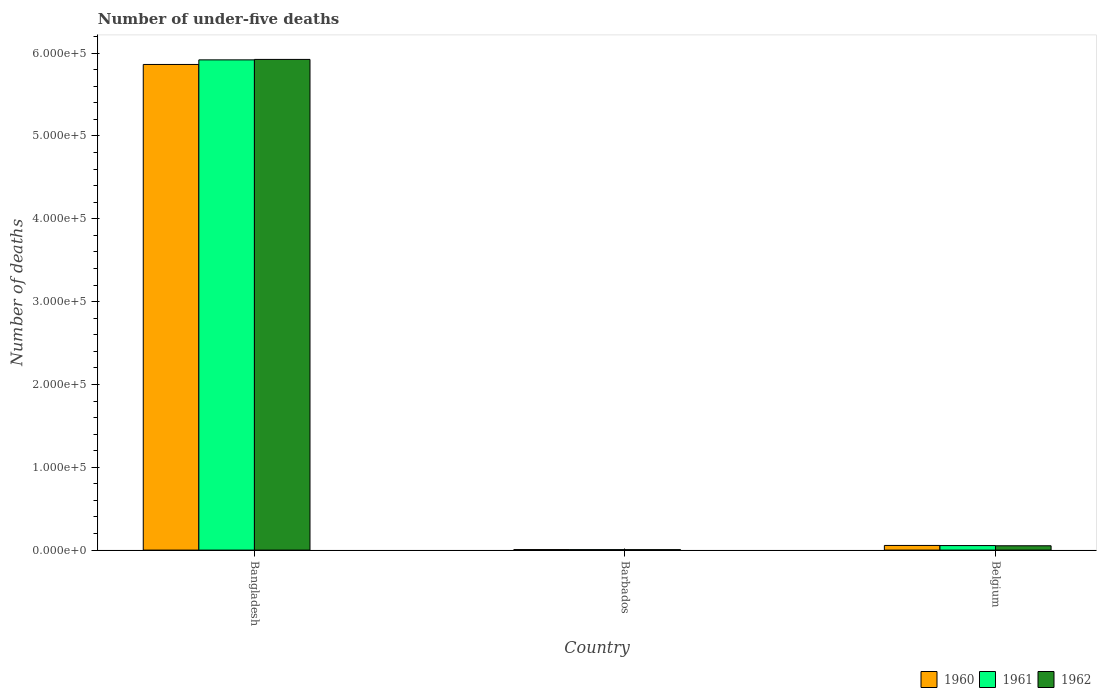How many groups of bars are there?
Give a very brief answer. 3. Are the number of bars per tick equal to the number of legend labels?
Give a very brief answer. Yes. How many bars are there on the 3rd tick from the left?
Provide a succinct answer. 3. How many bars are there on the 2nd tick from the right?
Your answer should be compact. 3. What is the label of the 2nd group of bars from the left?
Offer a terse response. Barbados. What is the number of under-five deaths in 1962 in Bangladesh?
Make the answer very short. 5.92e+05. Across all countries, what is the maximum number of under-five deaths in 1961?
Provide a short and direct response. 5.92e+05. Across all countries, what is the minimum number of under-five deaths in 1960?
Provide a short and direct response. 615. In which country was the number of under-five deaths in 1962 maximum?
Offer a very short reply. Bangladesh. In which country was the number of under-five deaths in 1961 minimum?
Offer a terse response. Barbados. What is the total number of under-five deaths in 1962 in the graph?
Make the answer very short. 5.98e+05. What is the difference between the number of under-five deaths in 1961 in Barbados and that in Belgium?
Offer a very short reply. -4887. What is the difference between the number of under-five deaths in 1962 in Bangladesh and the number of under-five deaths in 1961 in Belgium?
Provide a short and direct response. 5.87e+05. What is the average number of under-five deaths in 1960 per country?
Provide a succinct answer. 1.98e+05. What is the difference between the number of under-five deaths of/in 1962 and number of under-five deaths of/in 1961 in Belgium?
Provide a short and direct response. -232. What is the ratio of the number of under-five deaths in 1960 in Bangladesh to that in Barbados?
Keep it short and to the point. 953.38. What is the difference between the highest and the second highest number of under-five deaths in 1962?
Your response must be concise. -5.92e+05. What is the difference between the highest and the lowest number of under-five deaths in 1961?
Offer a very short reply. 5.91e+05. In how many countries, is the number of under-five deaths in 1960 greater than the average number of under-five deaths in 1960 taken over all countries?
Offer a very short reply. 1. Is the sum of the number of under-five deaths in 1961 in Bangladesh and Belgium greater than the maximum number of under-five deaths in 1962 across all countries?
Make the answer very short. Yes. How many bars are there?
Ensure brevity in your answer.  9. Does the graph contain any zero values?
Give a very brief answer. No. Does the graph contain grids?
Give a very brief answer. No. How are the legend labels stacked?
Provide a succinct answer. Horizontal. What is the title of the graph?
Provide a succinct answer. Number of under-five deaths. Does "1967" appear as one of the legend labels in the graph?
Ensure brevity in your answer.  No. What is the label or title of the X-axis?
Offer a terse response. Country. What is the label or title of the Y-axis?
Give a very brief answer. Number of deaths. What is the Number of deaths in 1960 in Bangladesh?
Your answer should be compact. 5.86e+05. What is the Number of deaths of 1961 in Bangladesh?
Provide a succinct answer. 5.92e+05. What is the Number of deaths of 1962 in Bangladesh?
Your response must be concise. 5.92e+05. What is the Number of deaths of 1960 in Barbados?
Provide a succinct answer. 615. What is the Number of deaths of 1961 in Barbados?
Provide a short and direct response. 574. What is the Number of deaths of 1962 in Barbados?
Provide a succinct answer. 536. What is the Number of deaths of 1960 in Belgium?
Ensure brevity in your answer.  5614. What is the Number of deaths of 1961 in Belgium?
Provide a succinct answer. 5461. What is the Number of deaths of 1962 in Belgium?
Provide a succinct answer. 5229. Across all countries, what is the maximum Number of deaths in 1960?
Ensure brevity in your answer.  5.86e+05. Across all countries, what is the maximum Number of deaths in 1961?
Offer a very short reply. 5.92e+05. Across all countries, what is the maximum Number of deaths in 1962?
Provide a short and direct response. 5.92e+05. Across all countries, what is the minimum Number of deaths of 1960?
Keep it short and to the point. 615. Across all countries, what is the minimum Number of deaths of 1961?
Give a very brief answer. 574. Across all countries, what is the minimum Number of deaths of 1962?
Offer a terse response. 536. What is the total Number of deaths in 1960 in the graph?
Your answer should be compact. 5.93e+05. What is the total Number of deaths in 1961 in the graph?
Your response must be concise. 5.98e+05. What is the total Number of deaths in 1962 in the graph?
Your answer should be compact. 5.98e+05. What is the difference between the Number of deaths of 1960 in Bangladesh and that in Barbados?
Keep it short and to the point. 5.86e+05. What is the difference between the Number of deaths in 1961 in Bangladesh and that in Barbados?
Provide a short and direct response. 5.91e+05. What is the difference between the Number of deaths in 1962 in Bangladesh and that in Barbados?
Give a very brief answer. 5.92e+05. What is the difference between the Number of deaths in 1960 in Bangladesh and that in Belgium?
Your answer should be very brief. 5.81e+05. What is the difference between the Number of deaths in 1961 in Bangladesh and that in Belgium?
Your answer should be compact. 5.86e+05. What is the difference between the Number of deaths in 1962 in Bangladesh and that in Belgium?
Provide a succinct answer. 5.87e+05. What is the difference between the Number of deaths of 1960 in Barbados and that in Belgium?
Provide a succinct answer. -4999. What is the difference between the Number of deaths in 1961 in Barbados and that in Belgium?
Offer a very short reply. -4887. What is the difference between the Number of deaths of 1962 in Barbados and that in Belgium?
Offer a very short reply. -4693. What is the difference between the Number of deaths of 1960 in Bangladesh and the Number of deaths of 1961 in Barbados?
Your response must be concise. 5.86e+05. What is the difference between the Number of deaths of 1960 in Bangladesh and the Number of deaths of 1962 in Barbados?
Your answer should be compact. 5.86e+05. What is the difference between the Number of deaths of 1961 in Bangladesh and the Number of deaths of 1962 in Barbados?
Keep it short and to the point. 5.91e+05. What is the difference between the Number of deaths in 1960 in Bangladesh and the Number of deaths in 1961 in Belgium?
Offer a very short reply. 5.81e+05. What is the difference between the Number of deaths in 1960 in Bangladesh and the Number of deaths in 1962 in Belgium?
Provide a short and direct response. 5.81e+05. What is the difference between the Number of deaths of 1961 in Bangladesh and the Number of deaths of 1962 in Belgium?
Offer a terse response. 5.87e+05. What is the difference between the Number of deaths in 1960 in Barbados and the Number of deaths in 1961 in Belgium?
Your response must be concise. -4846. What is the difference between the Number of deaths in 1960 in Barbados and the Number of deaths in 1962 in Belgium?
Keep it short and to the point. -4614. What is the difference between the Number of deaths of 1961 in Barbados and the Number of deaths of 1962 in Belgium?
Keep it short and to the point. -4655. What is the average Number of deaths of 1960 per country?
Your response must be concise. 1.98e+05. What is the average Number of deaths in 1961 per country?
Your answer should be very brief. 1.99e+05. What is the average Number of deaths in 1962 per country?
Give a very brief answer. 1.99e+05. What is the difference between the Number of deaths in 1960 and Number of deaths in 1961 in Bangladesh?
Offer a very short reply. -5561. What is the difference between the Number of deaths in 1960 and Number of deaths in 1962 in Bangladesh?
Your answer should be very brief. -6106. What is the difference between the Number of deaths in 1961 and Number of deaths in 1962 in Bangladesh?
Provide a succinct answer. -545. What is the difference between the Number of deaths in 1960 and Number of deaths in 1962 in Barbados?
Provide a short and direct response. 79. What is the difference between the Number of deaths of 1960 and Number of deaths of 1961 in Belgium?
Your response must be concise. 153. What is the difference between the Number of deaths in 1960 and Number of deaths in 1962 in Belgium?
Provide a short and direct response. 385. What is the difference between the Number of deaths of 1961 and Number of deaths of 1962 in Belgium?
Make the answer very short. 232. What is the ratio of the Number of deaths in 1960 in Bangladesh to that in Barbados?
Provide a short and direct response. 953.38. What is the ratio of the Number of deaths in 1961 in Bangladesh to that in Barbados?
Provide a short and direct response. 1031.17. What is the ratio of the Number of deaths of 1962 in Bangladesh to that in Barbados?
Offer a very short reply. 1105.29. What is the ratio of the Number of deaths of 1960 in Bangladesh to that in Belgium?
Your answer should be compact. 104.44. What is the ratio of the Number of deaths of 1961 in Bangladesh to that in Belgium?
Keep it short and to the point. 108.38. What is the ratio of the Number of deaths of 1962 in Bangladesh to that in Belgium?
Your response must be concise. 113.3. What is the ratio of the Number of deaths in 1960 in Barbados to that in Belgium?
Provide a succinct answer. 0.11. What is the ratio of the Number of deaths in 1961 in Barbados to that in Belgium?
Your response must be concise. 0.11. What is the ratio of the Number of deaths of 1962 in Barbados to that in Belgium?
Your response must be concise. 0.1. What is the difference between the highest and the second highest Number of deaths in 1960?
Ensure brevity in your answer.  5.81e+05. What is the difference between the highest and the second highest Number of deaths of 1961?
Your answer should be very brief. 5.86e+05. What is the difference between the highest and the second highest Number of deaths of 1962?
Give a very brief answer. 5.87e+05. What is the difference between the highest and the lowest Number of deaths of 1960?
Your answer should be very brief. 5.86e+05. What is the difference between the highest and the lowest Number of deaths in 1961?
Provide a short and direct response. 5.91e+05. What is the difference between the highest and the lowest Number of deaths in 1962?
Offer a terse response. 5.92e+05. 